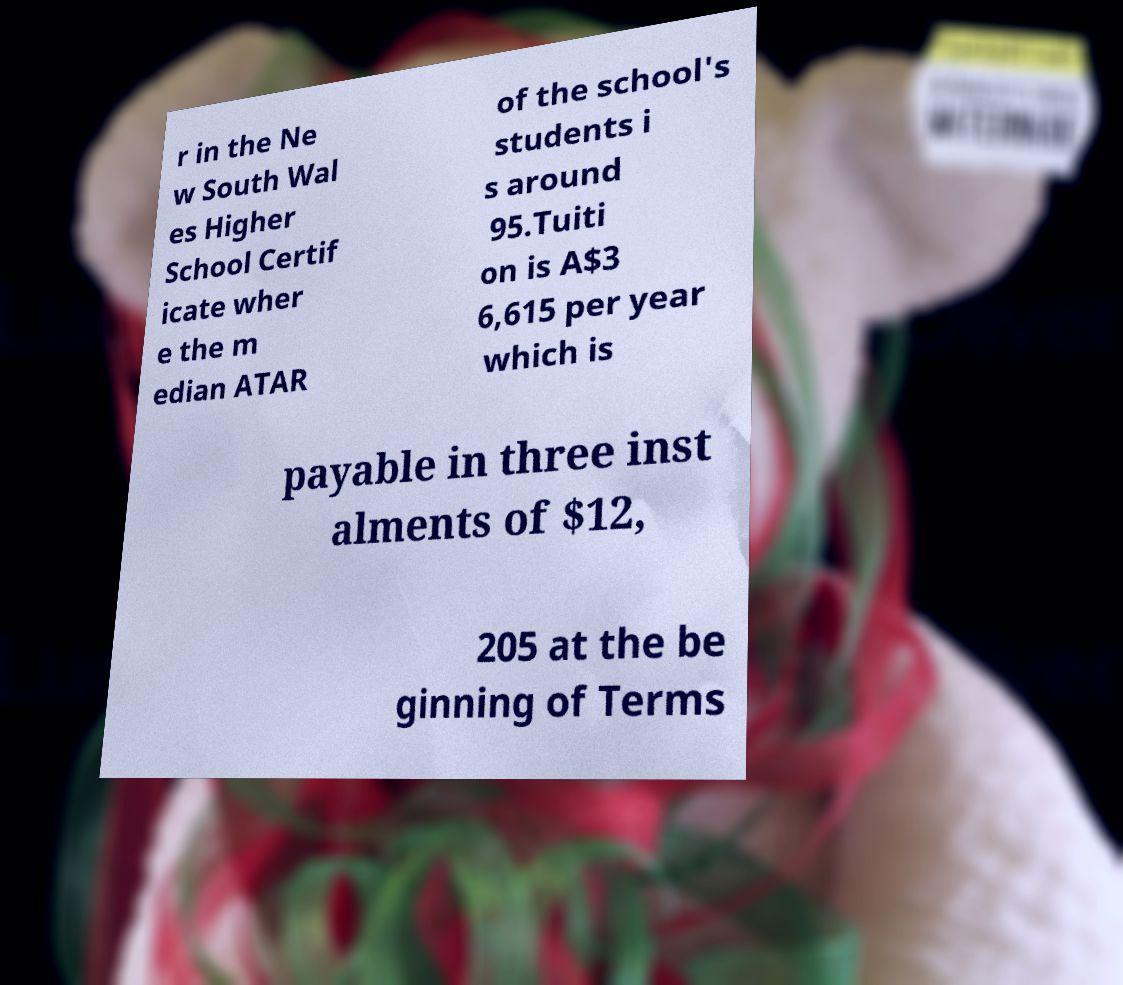Can you read and provide the text displayed in the image?This photo seems to have some interesting text. Can you extract and type it out for me? r in the Ne w South Wal es Higher School Certif icate wher e the m edian ATAR of the school's students i s around 95.Tuiti on is A$3 6,615 per year which is payable in three inst alments of $12, 205 at the be ginning of Terms 